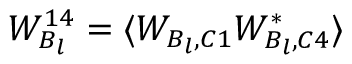<formula> <loc_0><loc_0><loc_500><loc_500>W _ { B _ { l } } ^ { 1 4 } = \langle W _ { B _ { l } , C 1 } W _ { B _ { l } , C 4 } ^ { * } \rangle</formula> 